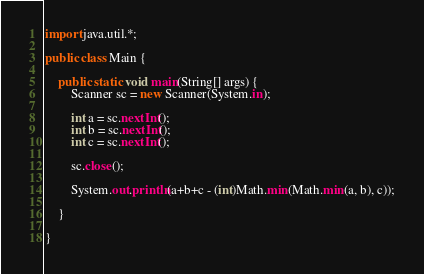<code> <loc_0><loc_0><loc_500><loc_500><_Java_>import java.util.*;

public class Main {

	public static void main(String[] args) {
		Scanner sc = new Scanner(System.in);
		
		int a = sc.nextInt();
		int b = sc.nextInt();
		int c = sc.nextInt();
		
		sc.close();
		
		System.out.println(a+b+c - (int)Math.min(Math.min(a, b), c));

	}

}
</code> 